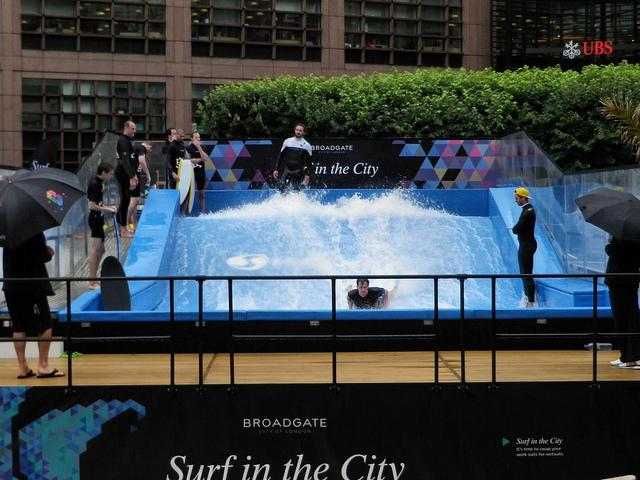What type of area is this event taking place at? city 